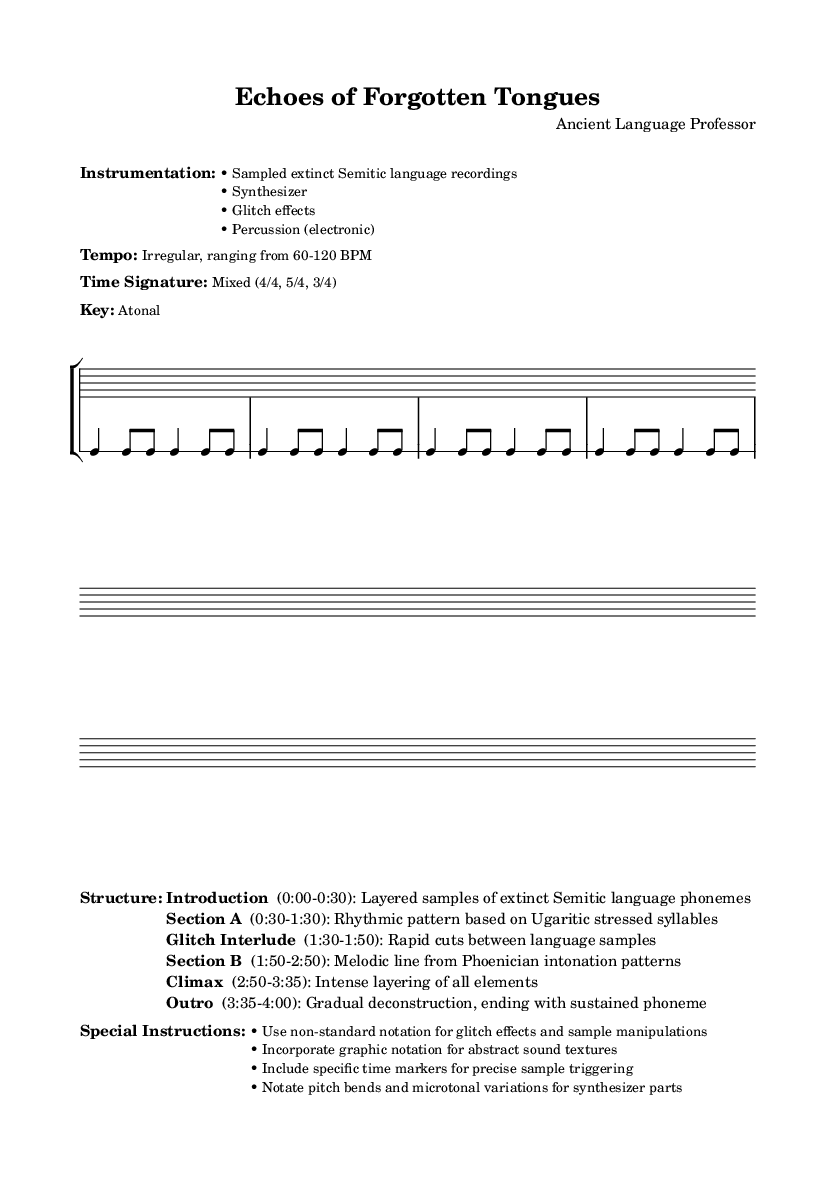What is the tempo range specified in the sheet music? The sheet music specifies that the tempo is irregular, ranging from 60-120 BPM. This information is found in the marked section titled "Tempo," where it explicitly states these values.
Answer: 60-120 BPM What time signatures are used in the piece? The time signatures indicated in the score indicate a mix of 4/4, 5/4, and 3/4 throughout the piece. This can be observed in the notes under the "Time Signature" section and the rhythmic staff sections.
Answer: Mixed (4/4, 5/4, 3/4) What type of instrumentation is listed for this composition? The instrumentation listed includes sampled extinct Semitic language recordings, synthesizer, glitch effects, and electronic percussion. This is detailed in the "Instrumentation" section within the markup.
Answer: Sampled extinct Semitic language recordings, synthesizer, glitch effects, electronic percussion How long is the "Climax" section in the composition? The "Climax" section is indicated to occur between 2:50 and 3:35, which gives a total duration of 45 seconds. To find this, subtract 2:50 from 3:35, which reveals the length of this section.
Answer: 45 seconds What is the key of this composition? The key of this composition is noted as atonal. This information can be found in the section labeled "Key" within the markup.
Answer: Atonal What is the first section of the piece titled? The first section of the piece is titled "Introduction." This title is listed in the "Structure" section along with the corresponding time frame.
Answer: Introduction What special instructions are provided for the performance of this piece? The special instructions include using non-standard notation for glitch effects and sample manipulations, incorporating graphic notation for abstract sound textures, and including specific time markers for sample triggering. This information is detailed in the "Special Instructions" section.
Answer: Use non-standard notation for glitch effects and sample manipulations; incorporate graphic notation for abstract sound textures; include specific time markers for sample triggering 